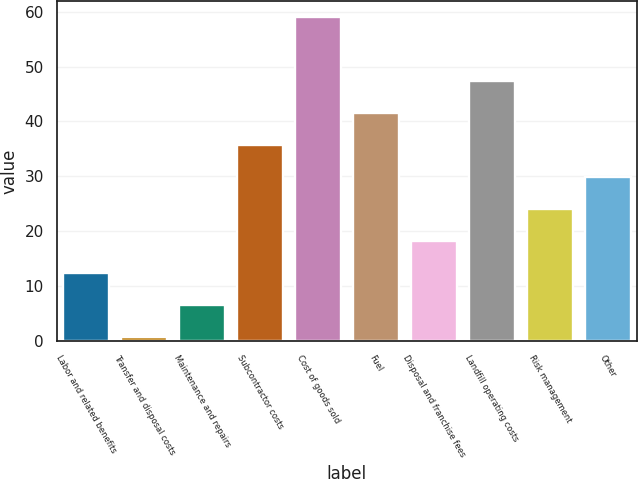Convert chart. <chart><loc_0><loc_0><loc_500><loc_500><bar_chart><fcel>Labor and related benefits<fcel>Transfer and disposal costs<fcel>Maintenance and repairs<fcel>Subcontractor costs<fcel>Cost of goods sold<fcel>Fuel<fcel>Disposal and franchise fees<fcel>Landfill operating costs<fcel>Risk management<fcel>Other<nl><fcel>12.28<fcel>0.6<fcel>6.44<fcel>35.64<fcel>59<fcel>41.48<fcel>18.12<fcel>47.32<fcel>23.96<fcel>29.8<nl></chart> 